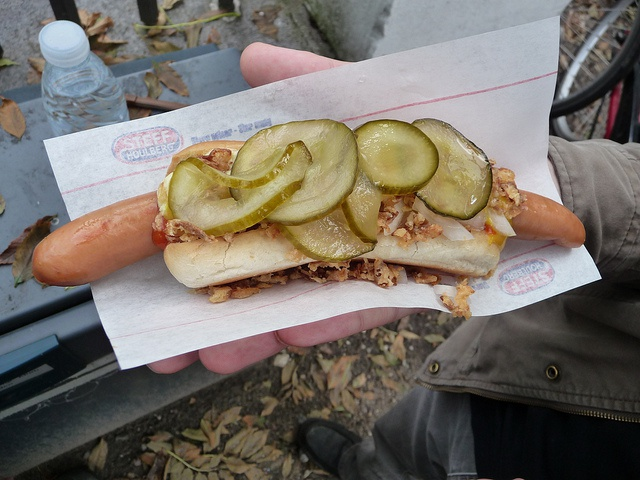Describe the objects in this image and their specific colors. I can see people in gray and black tones, hot dog in gray, tan, and olive tones, bicycle in gray, black, maroon, and darkgray tones, and bottle in gray and darkgray tones in this image. 